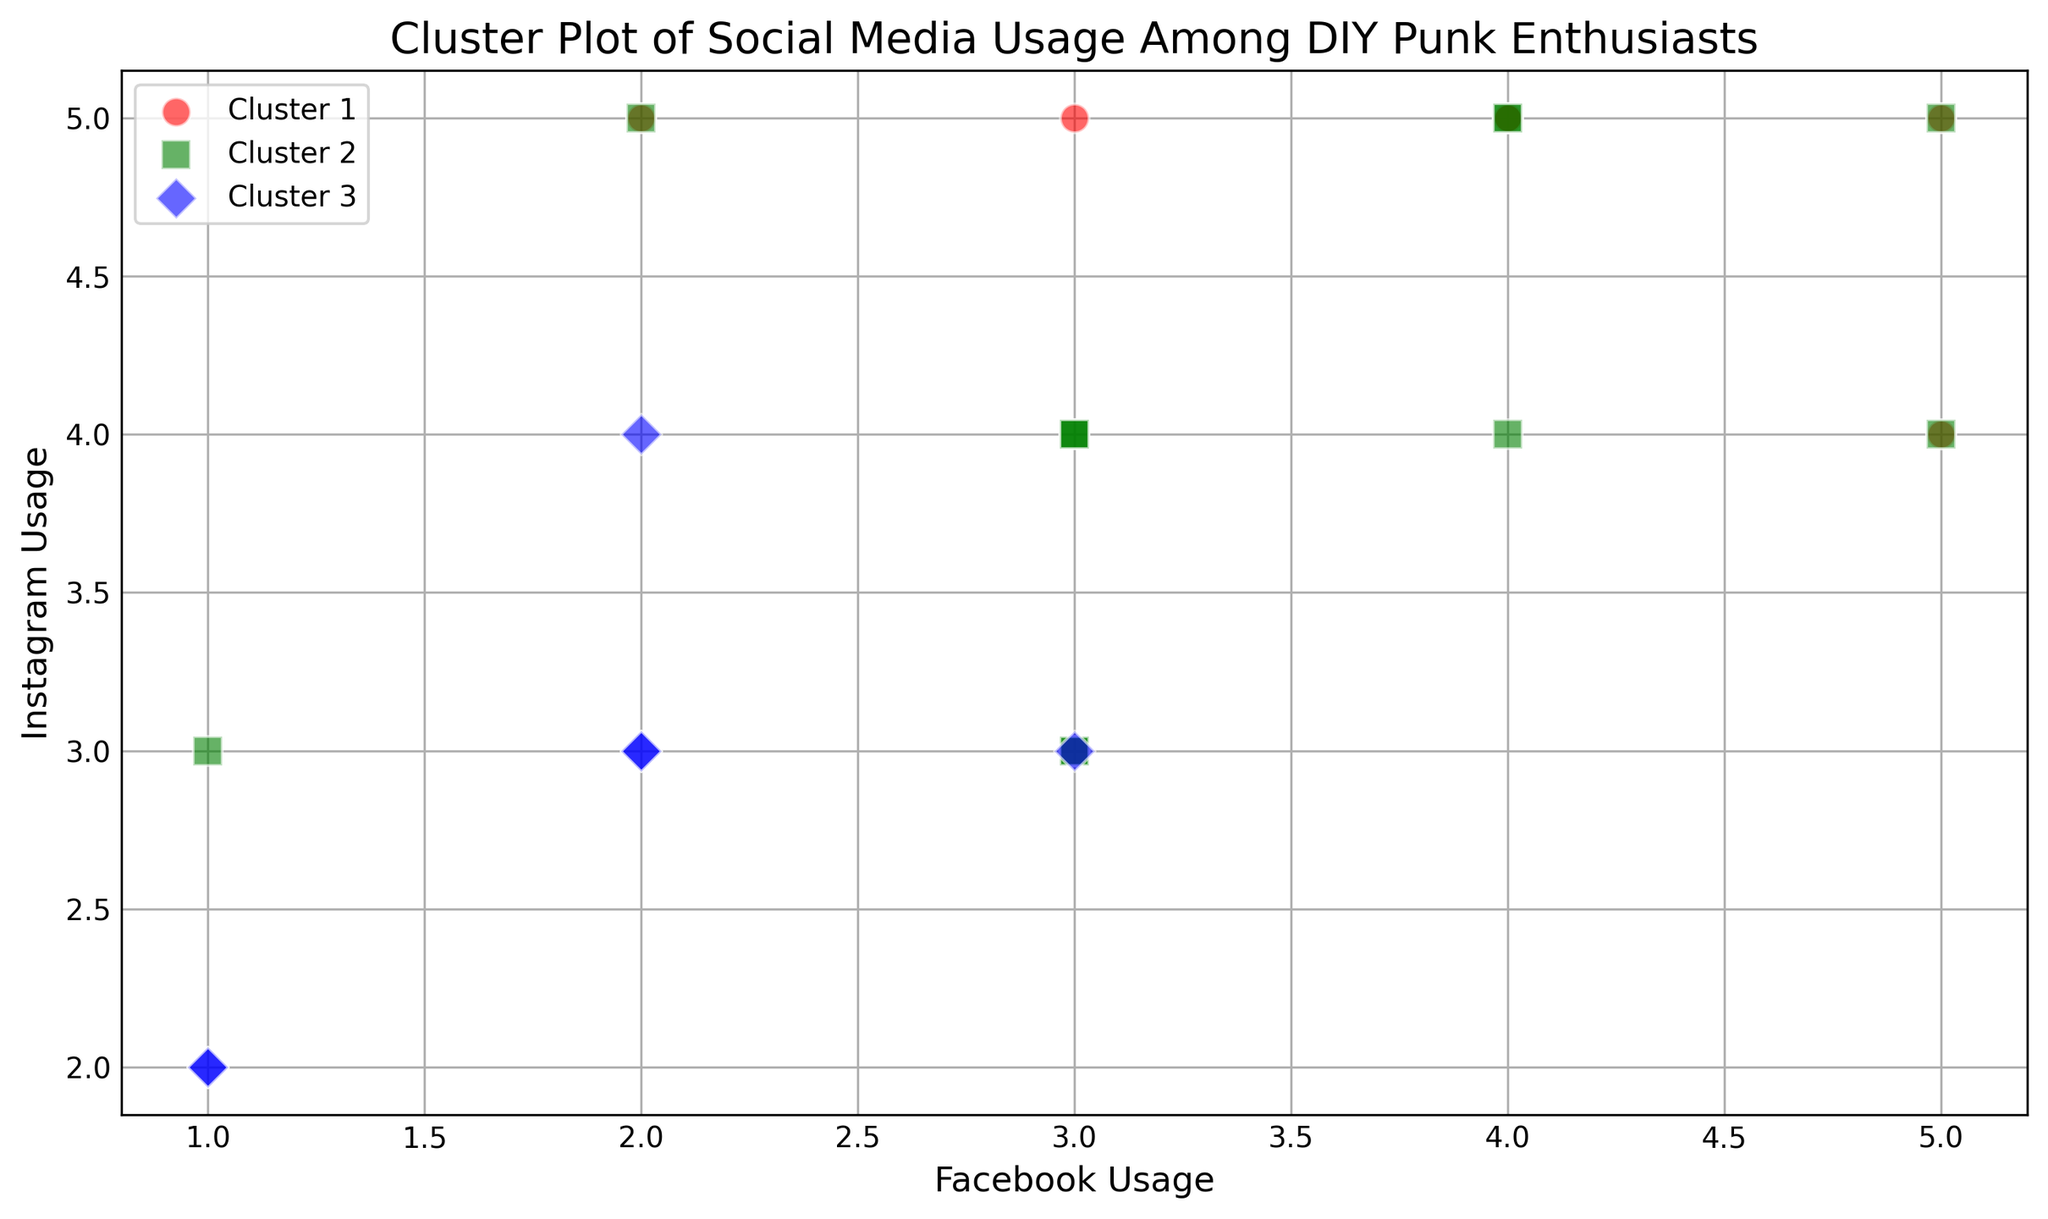What's the relationship between Facebook usage and Instagram usage in Cluster 1? Cluster 1 is color-coded in the figure. Look at the data points for Cluster 1 and compare the coordinates where Facebook usage is on the x-axis and Instagram usage is on the y-axis. All points should generally align into one specific pattern or trend.
Answer: More Facebook usage often goes with more Instagram usage Which cluster seems to have the highest Instagram usage? Identify which color and marker correspond to the highest points on the y-axis (Instagram usage). Compare the y-axis values across clusters.
Answer: Cluster 1 How many clusters are represented in the plot? Count the number of different colors or marker shapes in the scatter plot.
Answer: 3 Which cluster includes the highest Facebook usage point? Find the data point with the maximum x-axis value and identify which color and marker shape it belongs to.
Answer: Cluster 3 What's the highest value of Facebook usage in the plot? Look for the data point furthest to the right on the x-axis to determine the highest Facebook usage value.
Answer: 5 Which cluster appears most around the middle values of Facebook and Instagram usage? Visually inspect the plot and see which color and marker shape has the most points clustered around the center of the plot's x and y values.
Answer: Cluster 2 Are there any outliers in terms of Facebook usage? Check for any data points that are significantly separated from the other clusters along the x-axis (Facebook usage).
Answer: No significant outliers Do any clusters overlap significantly? Look for areas where different colors and shapes are closely packed together, indicating overlapping clusters.
Answer: Yes, Cluster 1 and Cluster 2 Is there a cluster that tends to have low values in both Facebook and Instagram usage? Identify which cluster has most of its points near the origin (low x and y values).
Answer: Cluster 3 